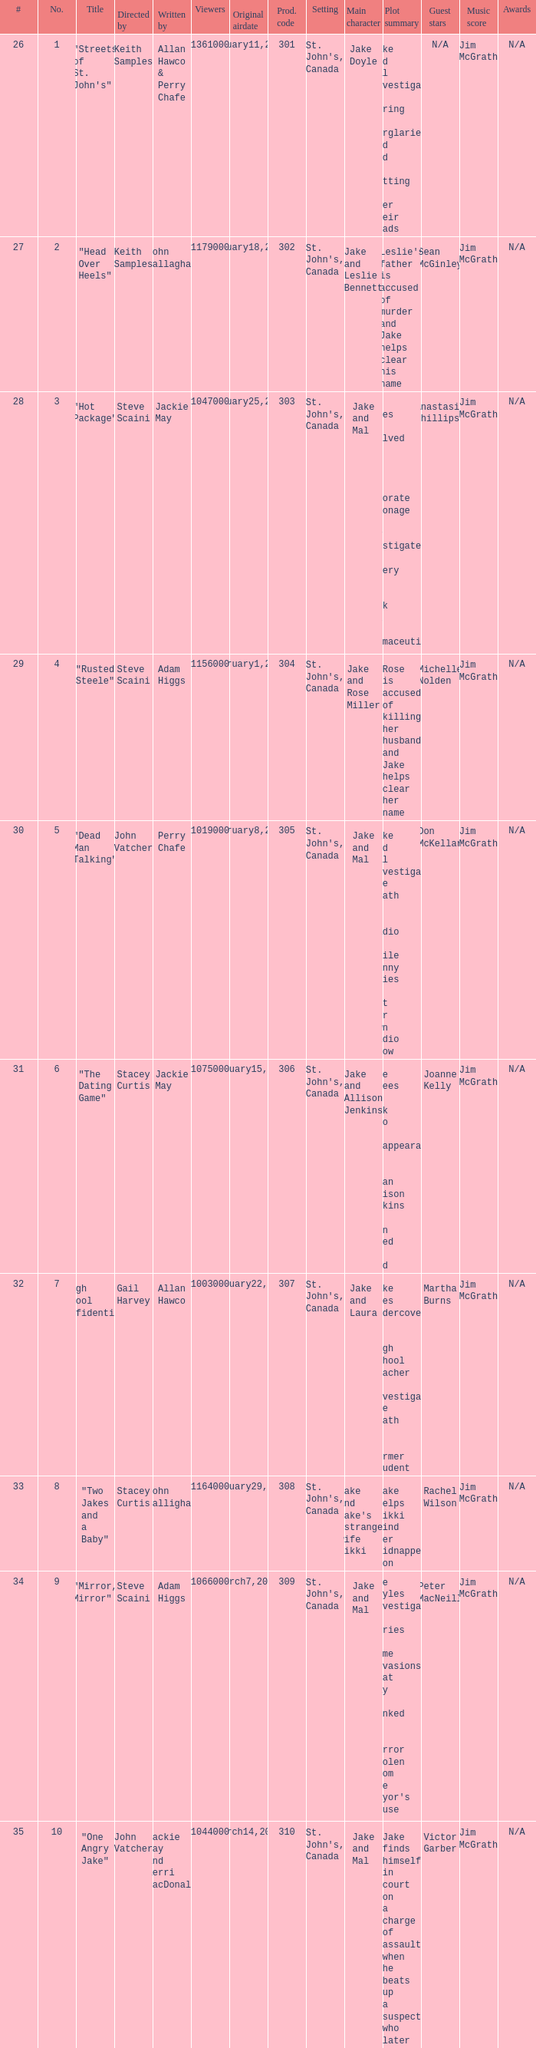What is the total number of films directy and written by john callaghan? 1.0. 